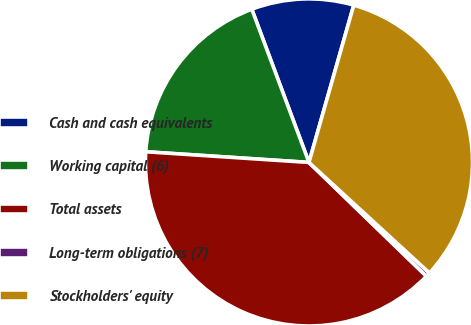<chart> <loc_0><loc_0><loc_500><loc_500><pie_chart><fcel>Cash and cash equivalents<fcel>Working capital (6)<fcel>Total assets<fcel>Long-term obligations (7)<fcel>Stockholders' equity<nl><fcel>10.1%<fcel>18.28%<fcel>38.8%<fcel>0.43%<fcel>32.41%<nl></chart> 